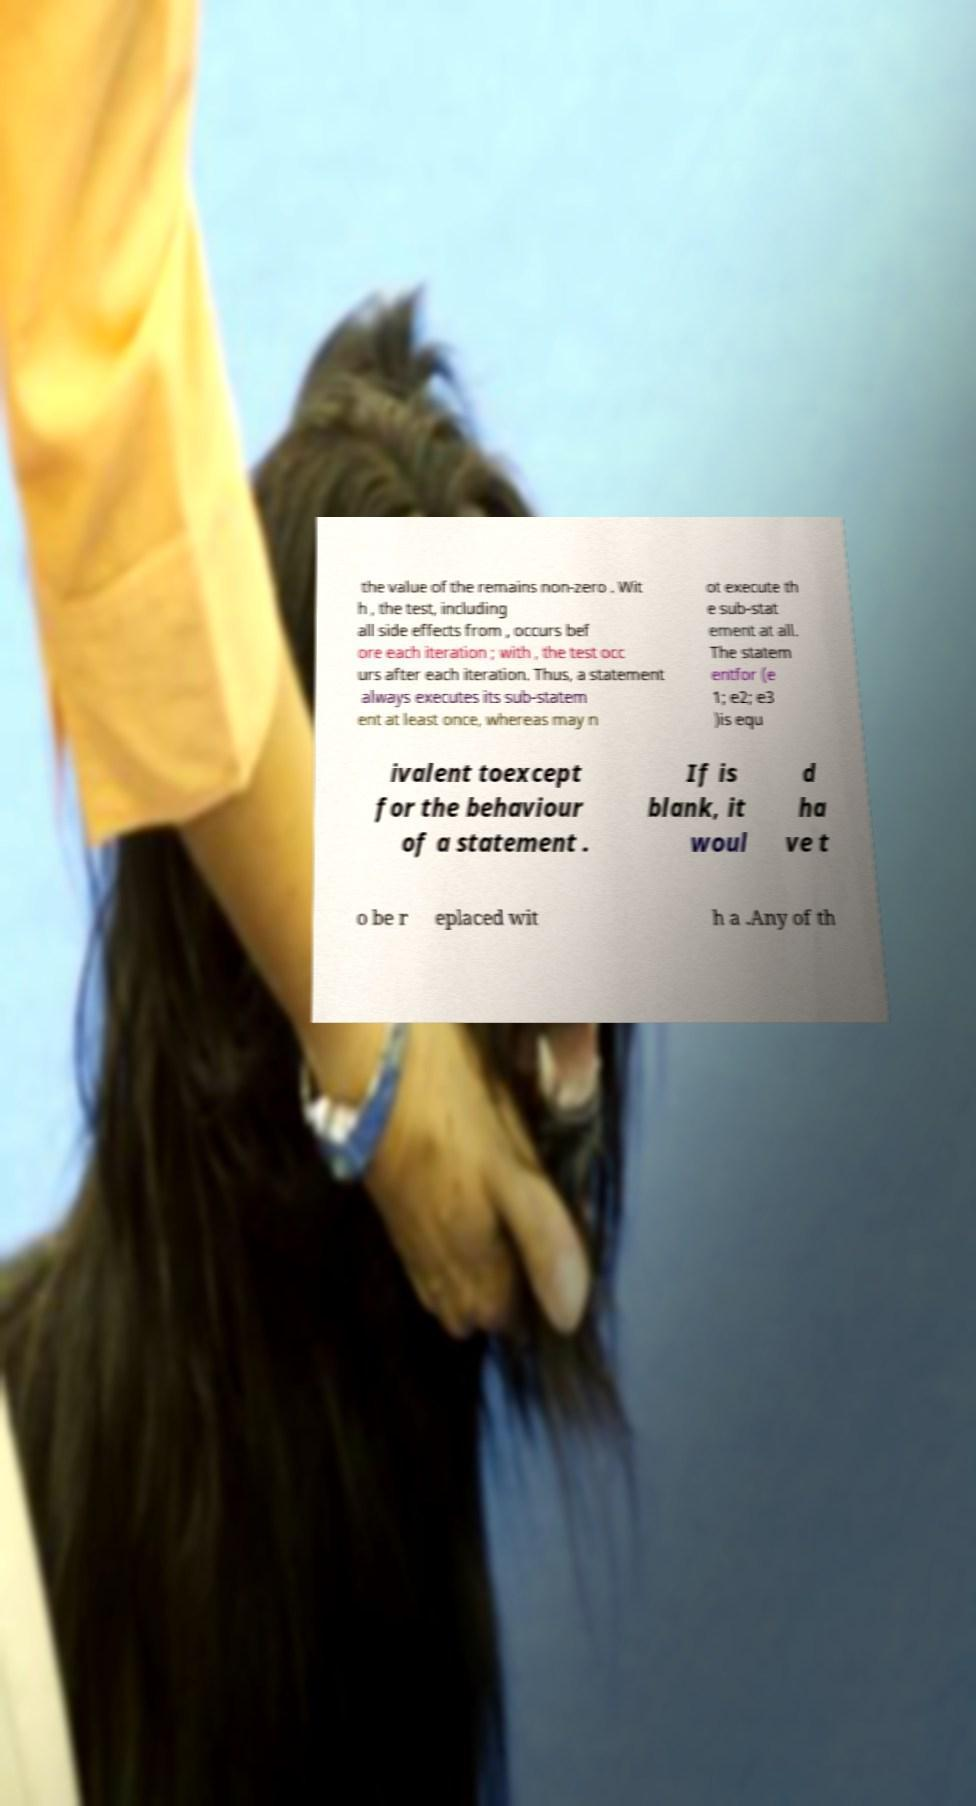Can you accurately transcribe the text from the provided image for me? the value of the remains non-zero . Wit h , the test, including all side effects from , occurs bef ore each iteration ; with , the test occ urs after each iteration. Thus, a statement always executes its sub-statem ent at least once, whereas may n ot execute th e sub-stat ement at all. The statem entfor (e 1; e2; e3 )is equ ivalent toexcept for the behaviour of a statement . If is blank, it woul d ha ve t o be r eplaced wit h a .Any of th 